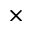<formula> <loc_0><loc_0><loc_500><loc_500>\times</formula> 